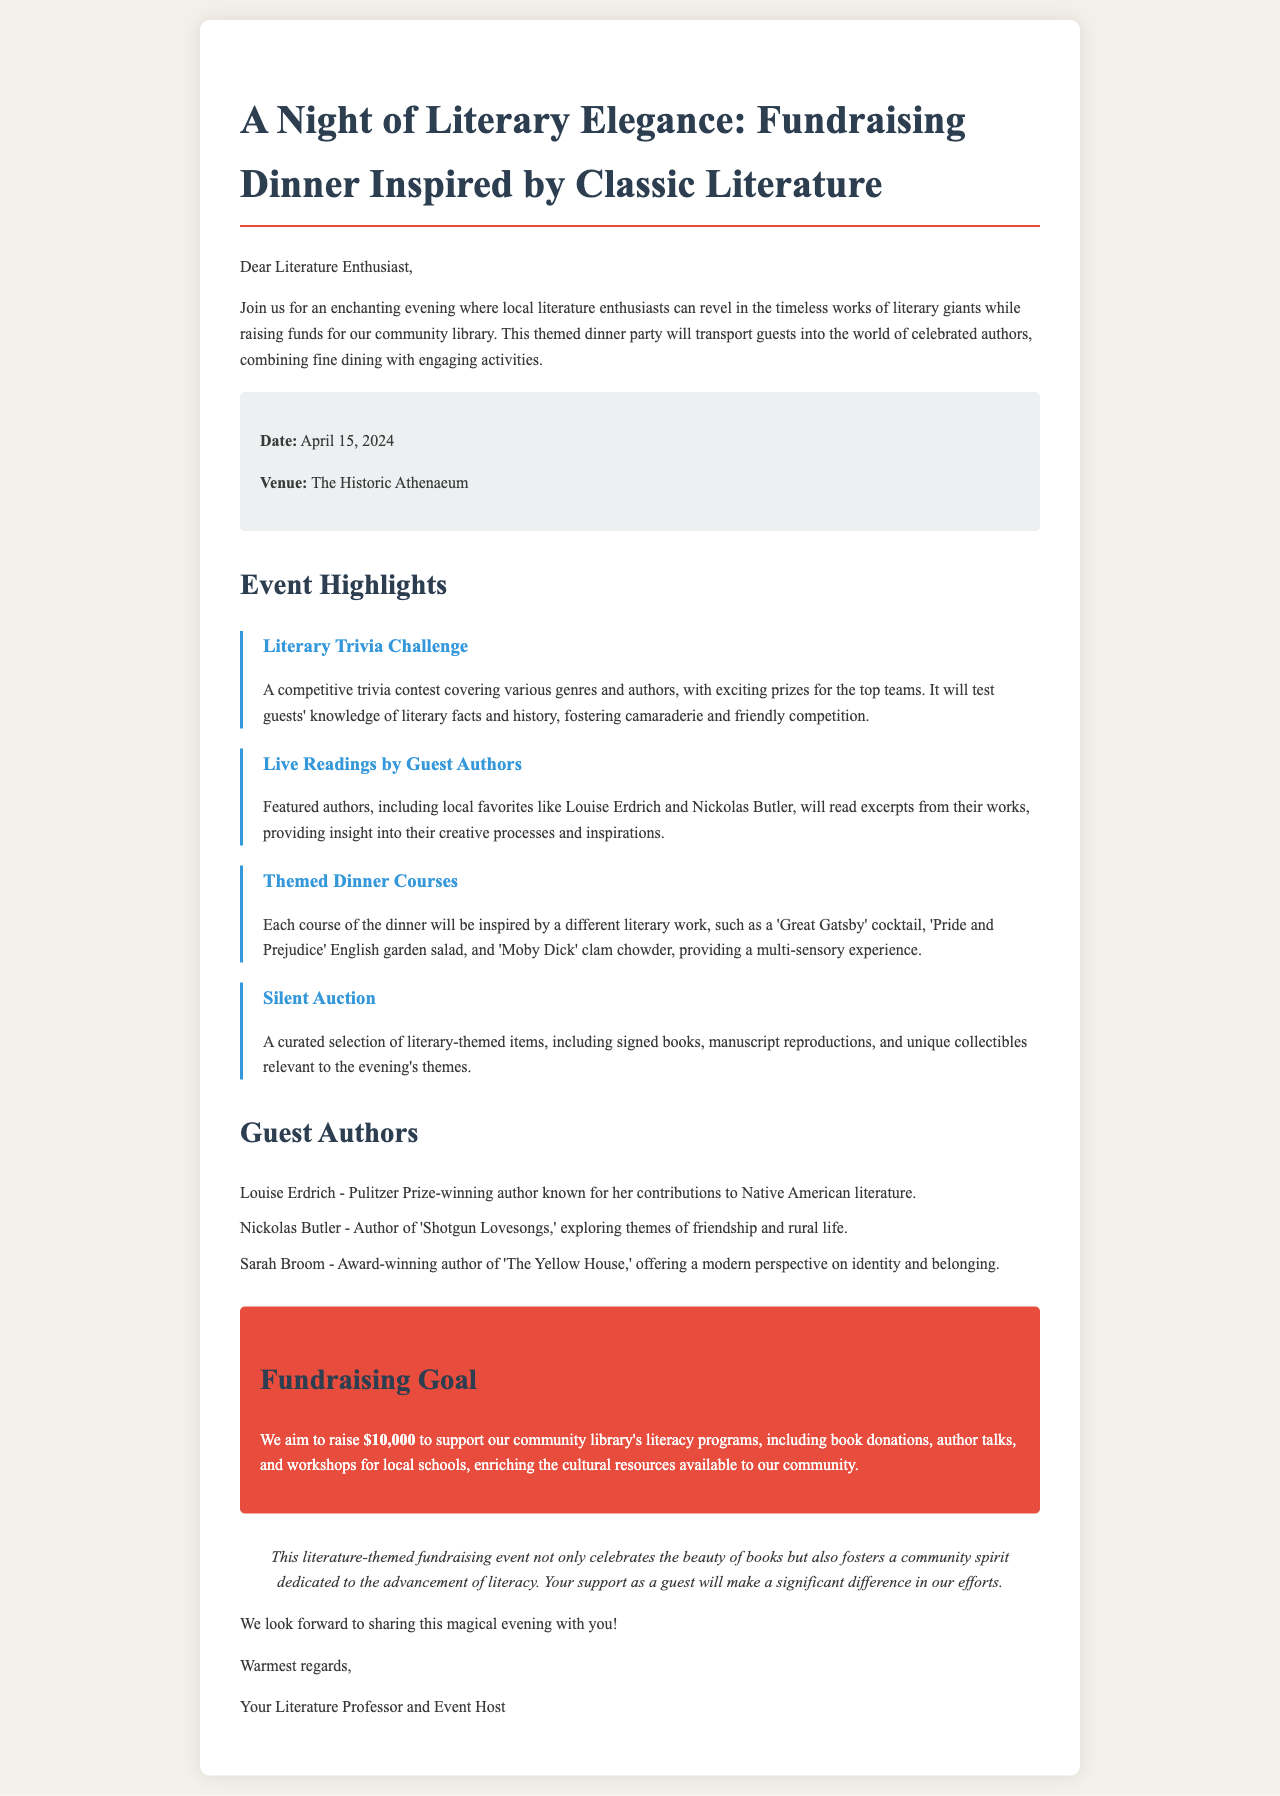What is the date of the event? The date of the event is specifically mentioned in the document, which states it will take place on April 15, 2024.
Answer: April 15, 2024 Where will the event take place? The venue for the event is provided in the document, stating that it will be held at The Historic Athenaeum.
Answer: The Historic Athenaeum What is the fundraising goal? The document outlines the fundraising goal as a specific amount, which is $10,000 to support community library programs.
Answer: $10,000 Who is one of the guest authors? The document lists guest authors, including Louise Erdrich, Nickolas Butler, and Sarah Broom; any of these could be an acceptable answer.
Answer: Louise Erdrich What activity involves a competitive contest? The document describes a specific activity as a competitive trivia contest, which is labeled as the Literary Trivia Challenge.
Answer: Literary Trivia Challenge What type of dinner courses will be served? The document details that each dinner course will be inspired by different literary works, indicating a themed dining experience.
Answer: Themed dinner courses How many guest authors are mentioned? The document lists three guest authors, and counting them provides the answer to this question.
Answer: Three What kind of items will be in the silent auction? The document specifically mentions that the silent auction will have literary-themed items, like signed books and manuscript reproductions.
Answer: Literary-themed items What is the primary purpose of the fundraising event? The document explains that the primary purpose is to raise funds for the community library's literacy programs.
Answer: Support community library's literacy programs 